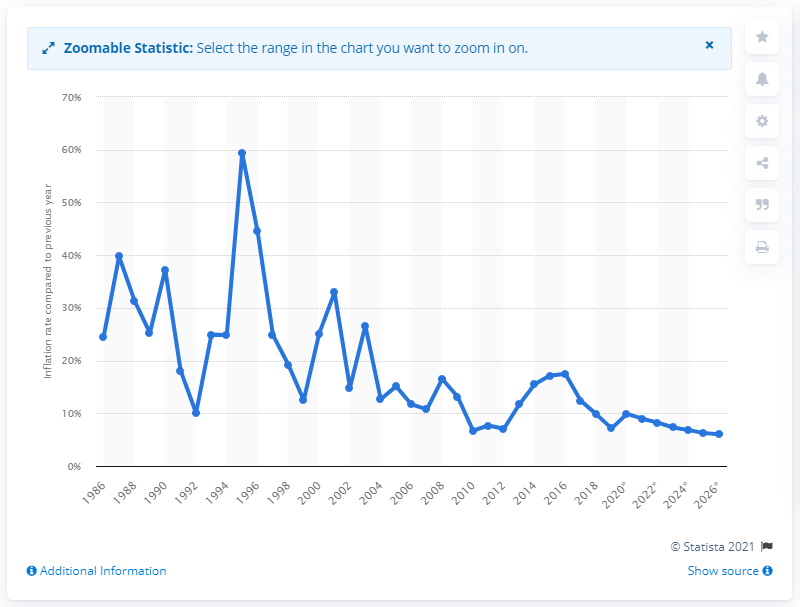Outline some significant characteristics in this image. The inflation rate in Ghana in 2018 was 9.89%. 